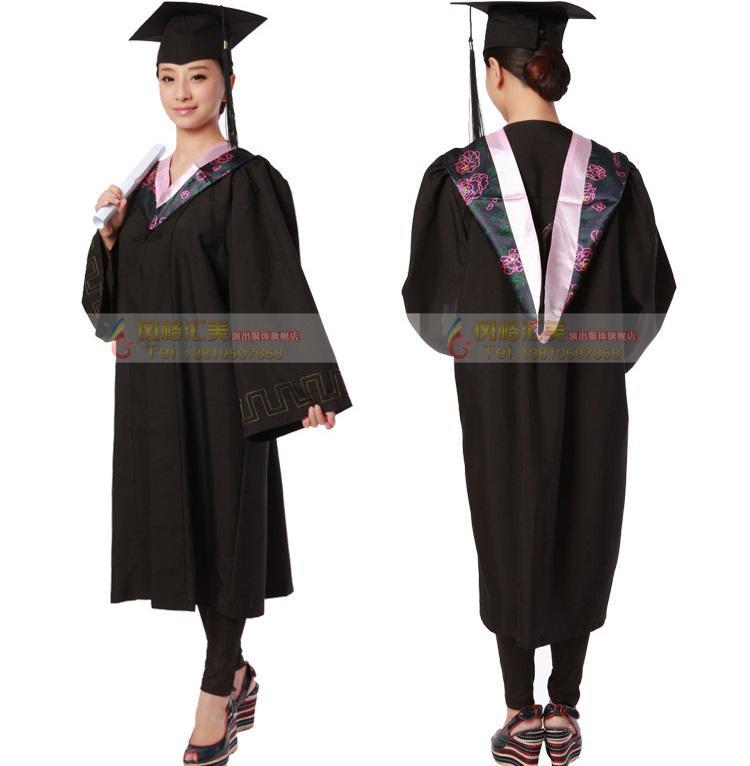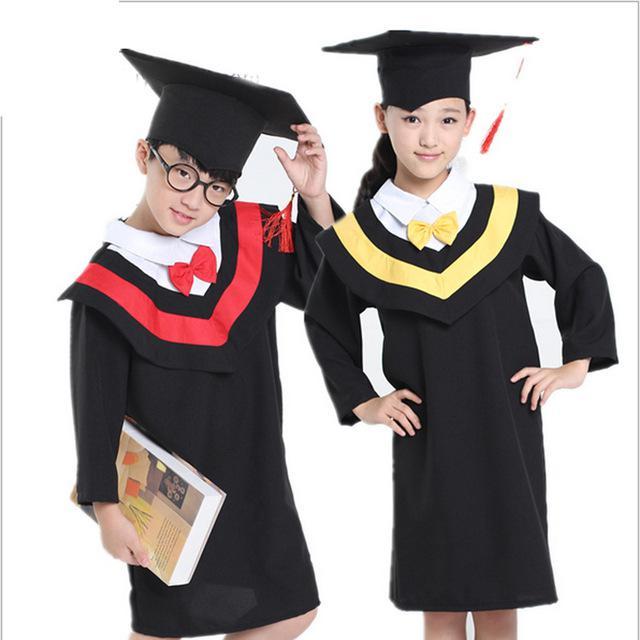The first image is the image on the left, the second image is the image on the right. Analyze the images presented: Is the assertion "A student is holding a diploma with her left hand and pointing with her right hand." valid? Answer yes or no. No. The first image is the image on the left, the second image is the image on the right. Assess this claim about the two images: "Someone is carrying a book next to someone who isn't carrying a book.". Correct or not? Answer yes or no. Yes. 